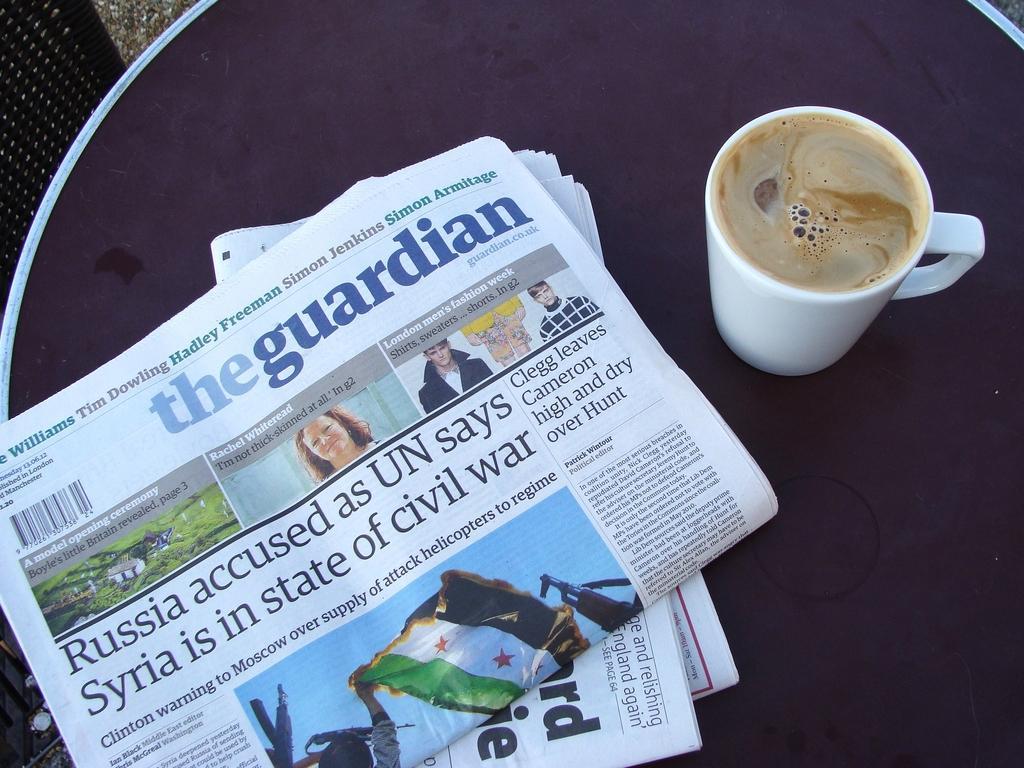How would you summarize this image in a sentence or two? In this image I can see there are few newspapers and a coffee mug placed on the table and there is a chair at left side. 